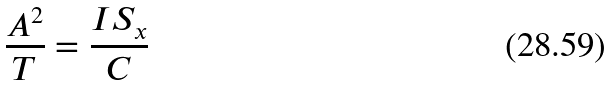<formula> <loc_0><loc_0><loc_500><loc_500>\frac { A ^ { 2 } } { T } = \frac { I S _ { x } } { C }</formula> 